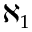Convert formula to latex. <formula><loc_0><loc_0><loc_500><loc_500>\aleph _ { 1 }</formula> 